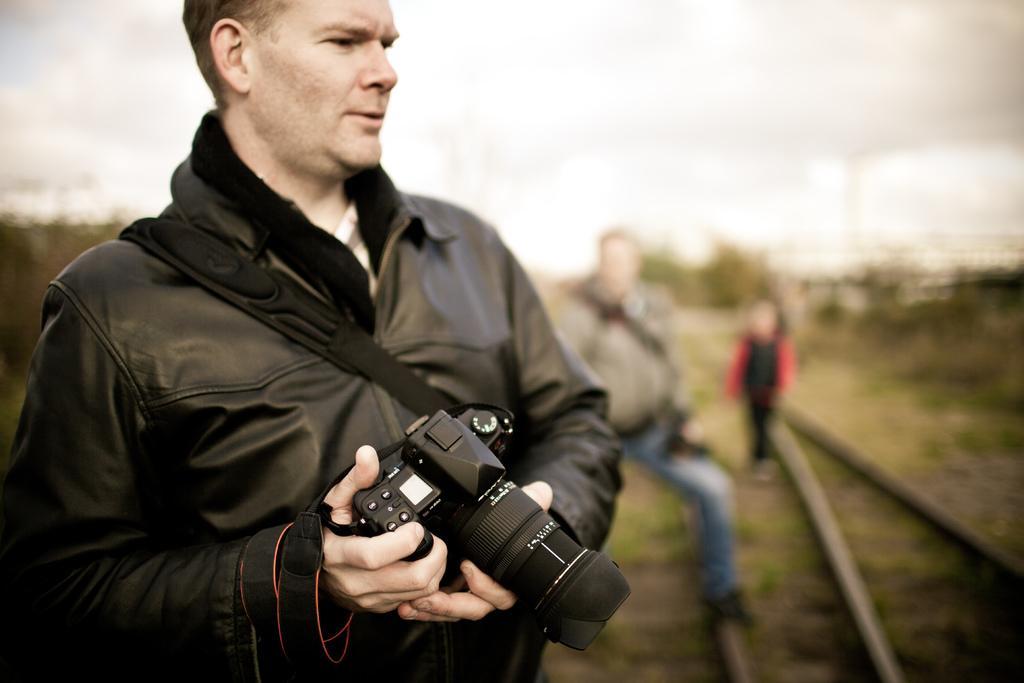Describe this image in one or two sentences. This picture is taken in a garden. The man to the left corner is wearing a black jacket and holding a camera in his hand. We can also see a bag stripe on his jacket. There are other two people standing behind him. Behind them there are trees and sky. The background is blurred. 